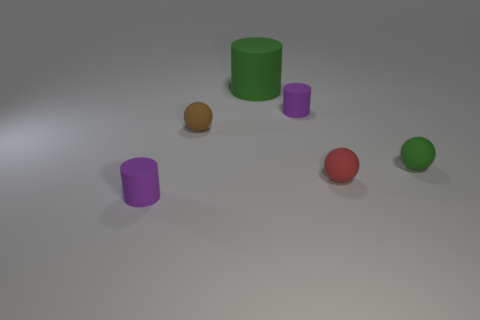Do the red object and the tiny brown matte thing have the same shape? Yes, both the red spherical object and the tiny brown matte object appear to have a round shape, suggesting that they are both spheres. 